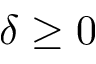<formula> <loc_0><loc_0><loc_500><loc_500>\delta \geq 0</formula> 